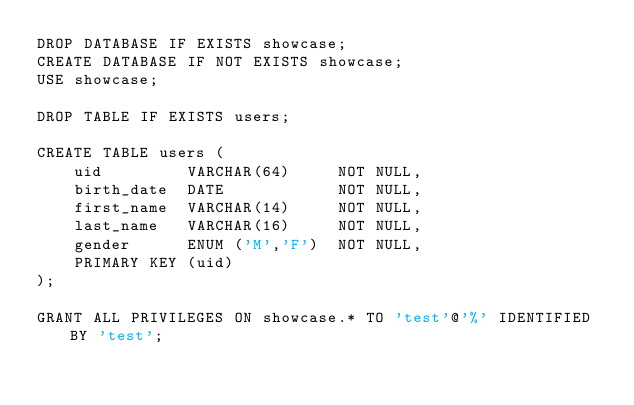Convert code to text. <code><loc_0><loc_0><loc_500><loc_500><_SQL_>DROP DATABASE IF EXISTS showcase;
CREATE DATABASE IF NOT EXISTS showcase;
USE showcase;

DROP TABLE IF EXISTS users;

CREATE TABLE users (
    uid         VARCHAR(64)     NOT NULL,
    birth_date  DATE            NOT NULL,
    first_name  VARCHAR(14)     NOT NULL,
    last_name   VARCHAR(16)     NOT NULL,
    gender      ENUM ('M','F')  NOT NULL,
    PRIMARY KEY (uid)
);

GRANT ALL PRIVILEGES ON showcase.* TO 'test'@'%' IDENTIFIED BY 'test';
</code> 